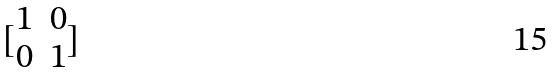Convert formula to latex. <formula><loc_0><loc_0><loc_500><loc_500>[ \begin{matrix} 1 & 0 \\ 0 & 1 \end{matrix} ]</formula> 